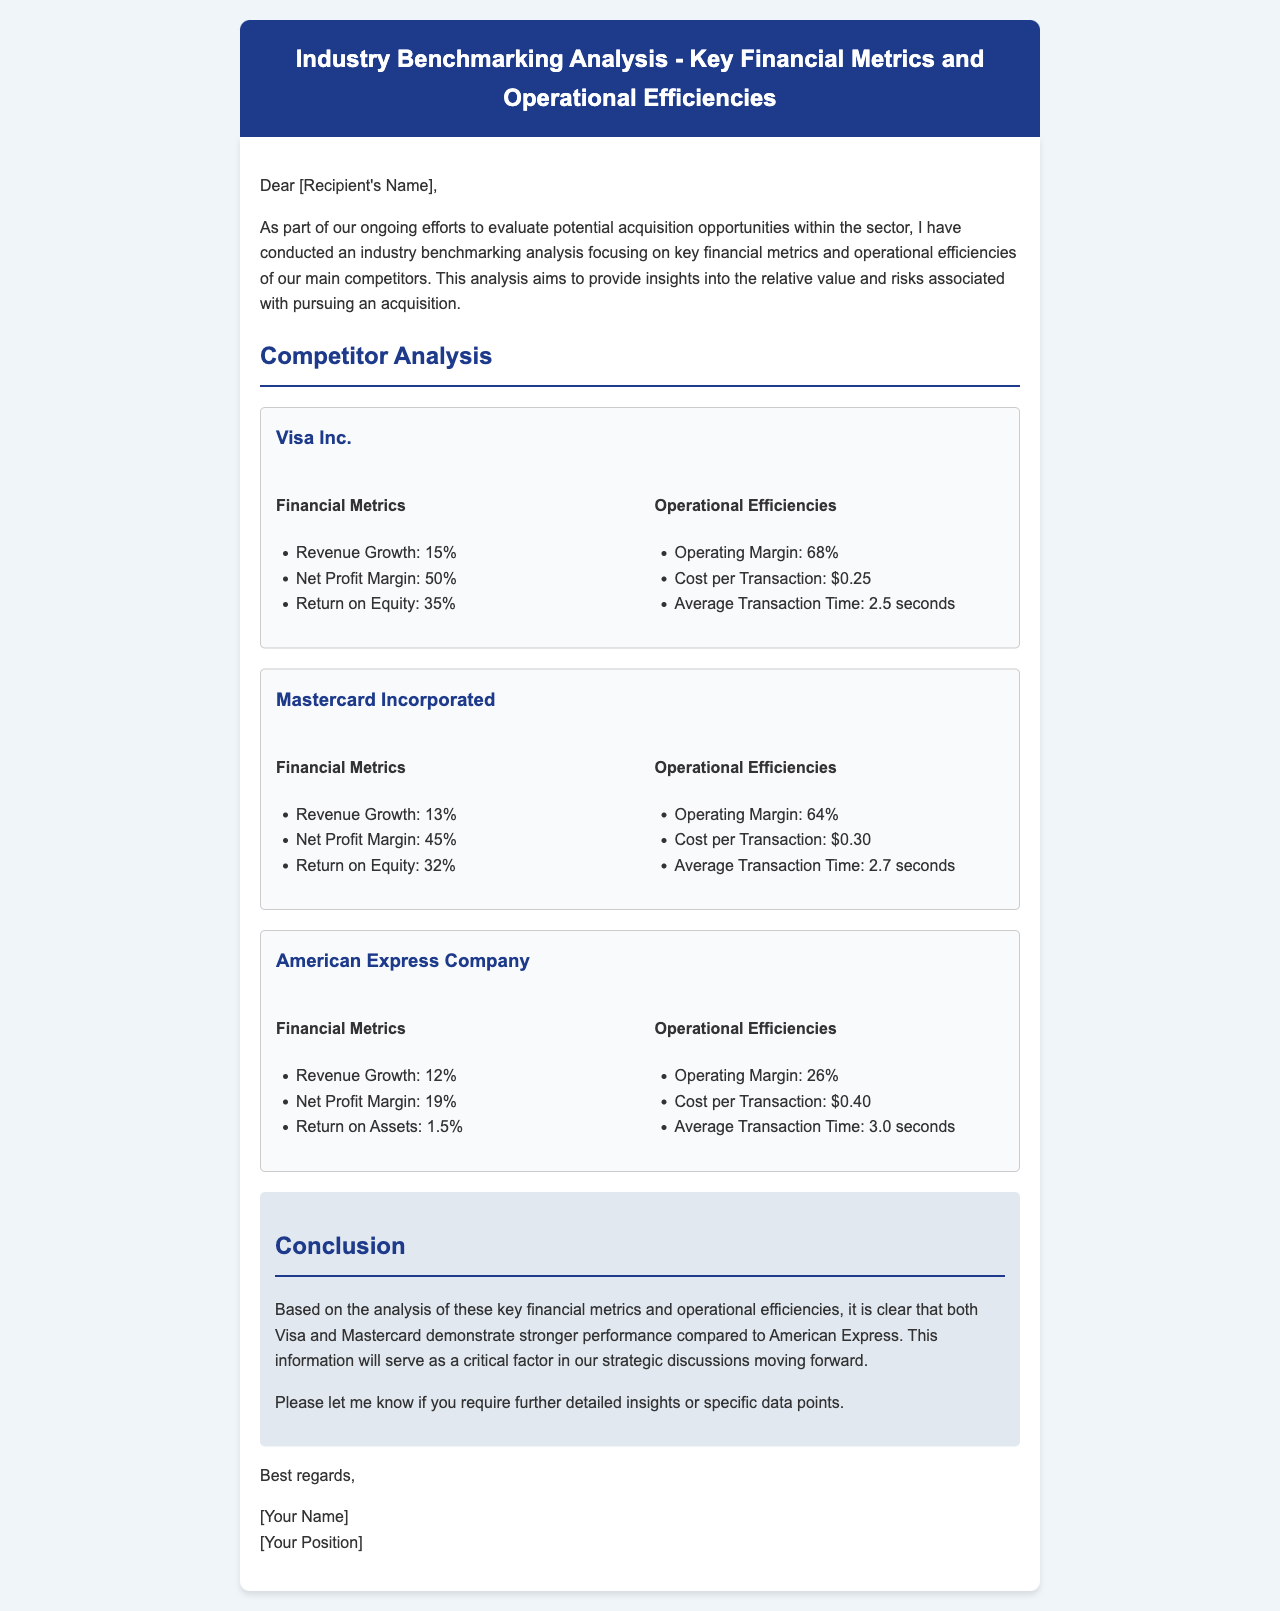What is the revenue growth for Visa Inc.? The revenue growth for Visa Inc. is listed in the financial metrics section under Visa Inc., which states 15%.
Answer: 15% What is the net profit margin for Mastercard Incorporated? The net profit margin is found in the financial metrics section for Mastercard, indicating it is 45%.
Answer: 45% What is the operating margin for American Express Company? The operating margin for American Express Company is provided in the operational efficiencies section and is shown as 26%.
Answer: 26% Which competitor has the highest return on equity? The return on equity figures for each competitor are compared, and Visa Inc. has the highest at 35%.
Answer: Visa Inc What is the cost per transaction for Mastercard Incorporated? The document lists the cost per transaction for Mastercard in the operational efficiencies section, which is $0.30.
Answer: $0.30 Which company has the highest net profit margin? By comparing the net profit margins of the companies, Visa Inc. has the highest at 50%.
Answer: Visa Inc What conclusion is drawn about American Express compared to Visa and Mastercard? The conclusion suggests that American Express demonstrates weaker performance than both Visa and Mastercard based on the analysis of metrics.
Answer: Weaker performance What does the document say about the average transaction time for Visa Inc.? The average transaction time for Visa is specified in the operational efficiencies section as 2.5 seconds.
Answer: 2.5 seconds What are the two main focuses of this industry benchmarking analysis? The analysis focuses on key financial metrics and operational efficiencies to evaluate acquisition opportunities.
Answer: Financial metrics and operational efficiencies 